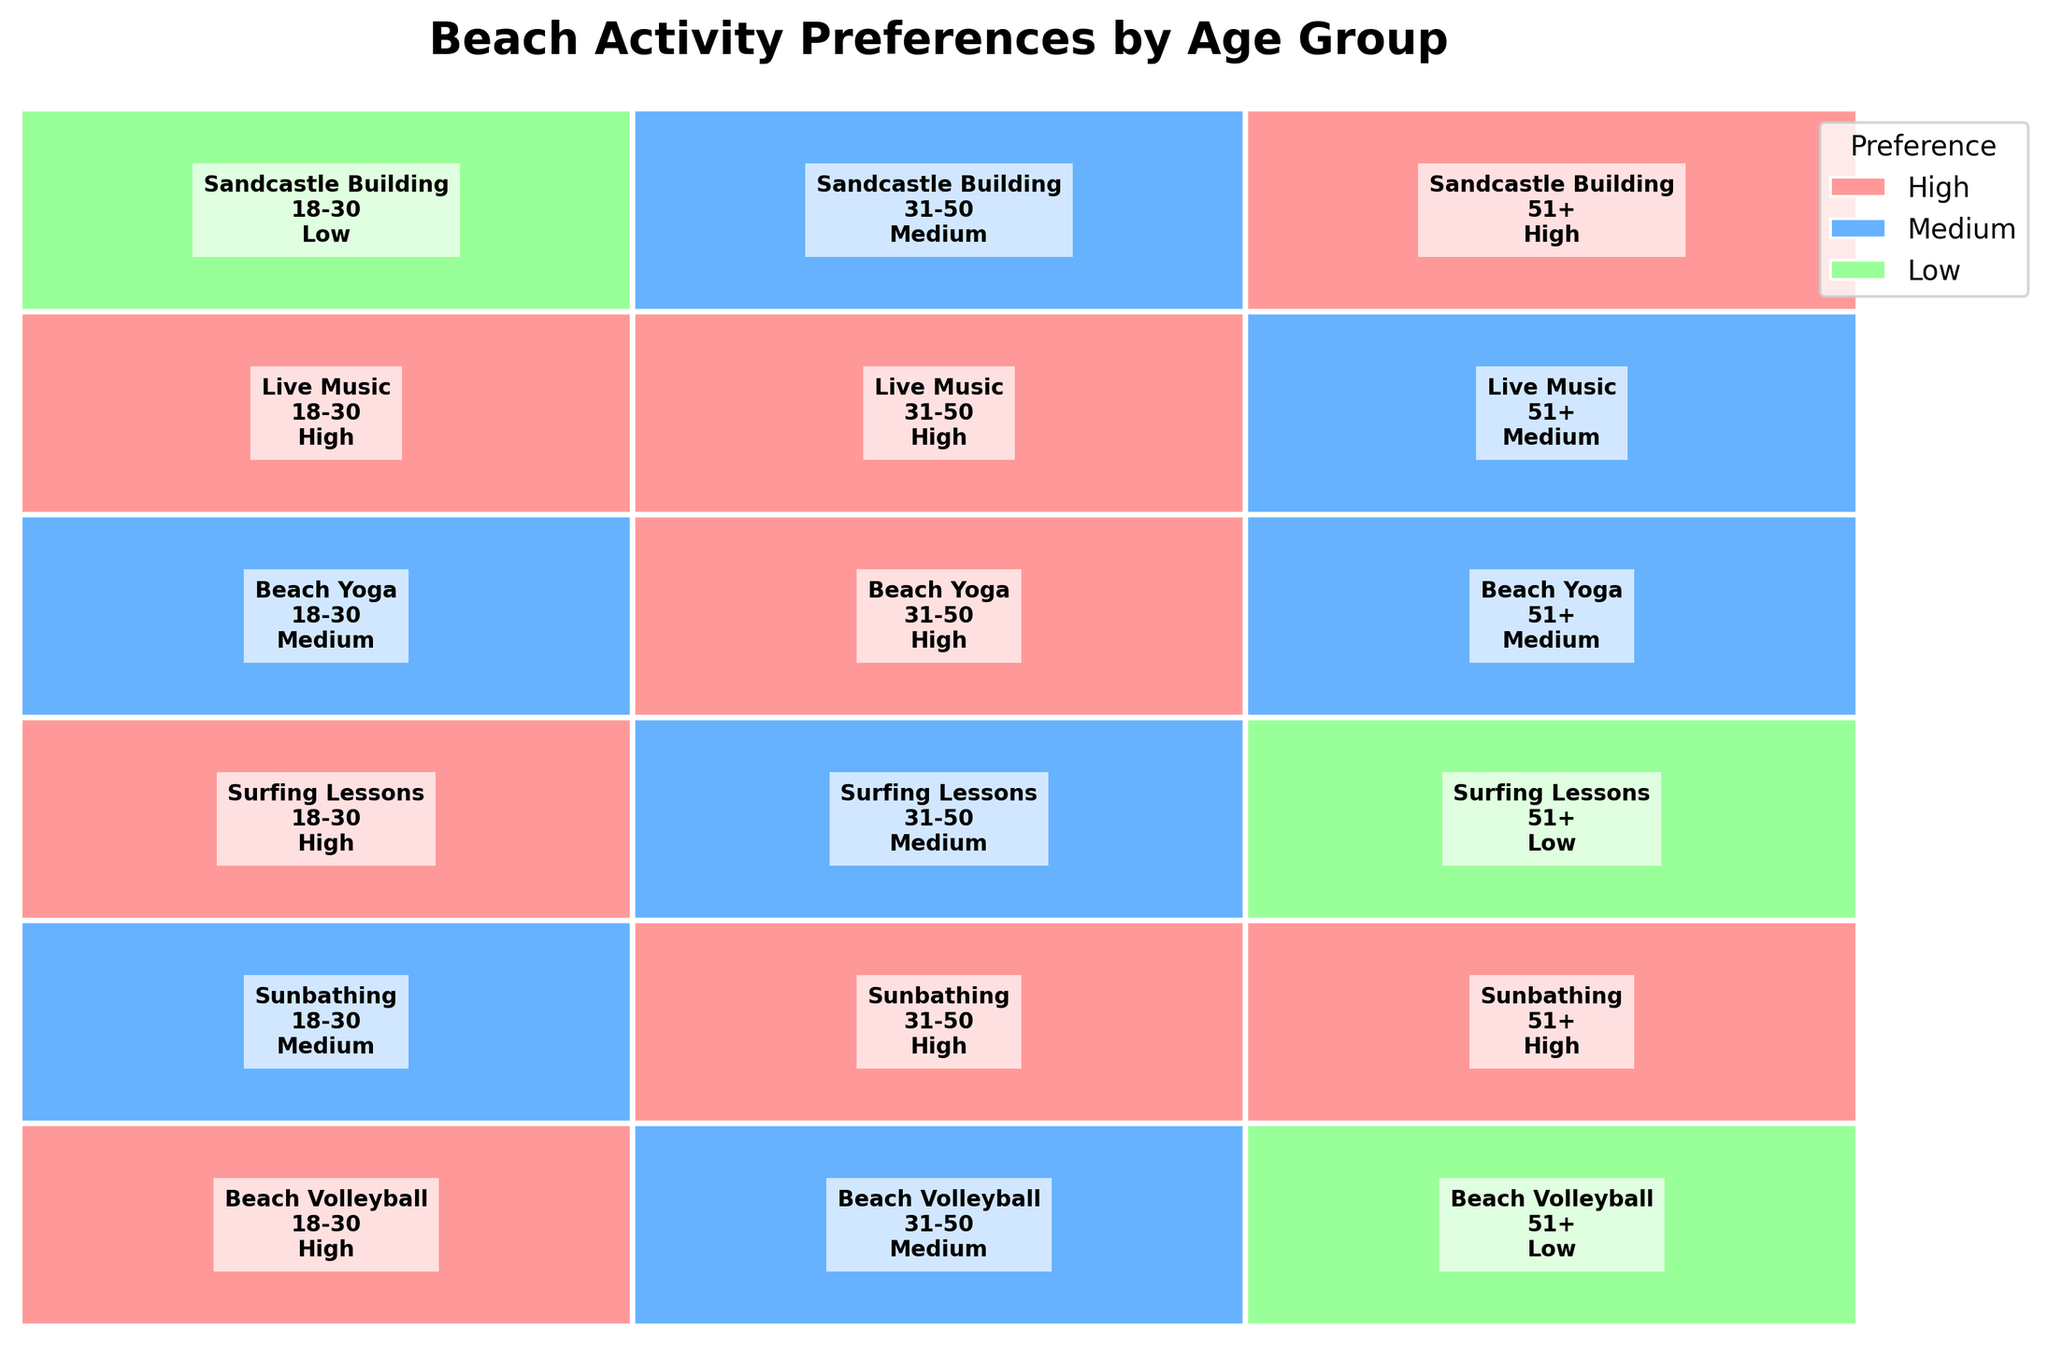What is the title of the plot? The title of the plot is written at the top of the figure. It says, "Beach Activity Preferences by Age Group."
Answer: Beach Activity Preferences by Age Group Which activity has the highest preference among the 18-30 age group? Looking at the section representing the 18-30 age group, "Live Music" has "High" preference color (light red) indicating it's the highest preference among this group.
Answer: Live Music Which age group has a low preference for Surfing Lessons? The section for "Surfing Lessons" can be identified, and within that, the "Low" preference color (light green) is associated with the age group 51+.
Answer: 51+ How do preferences for Beach Volleyball differ among the age groups? The 18-30 age group has a "High" preference (light red), 31-50 has a "Medium" preference (blue), and 51+ has a "Low" preference (light green) as indicated by the color coding in those sections.
Answer: 18-30: High, 31-50: Medium, 51+: Low Which activity do all age groups rate as high or medium? Looking across all age groups for each activity, "Sunbathing" and "Live Music" have "High" or "Medium" preferences across all age groups as shown by light red and blue sections.
Answer: Sunbathing and Live Music Do older age groups prefer Sandcastle Building more than the younger age groups? The preference for Sandcastle Building can be observed by noting colors for age groups - 51+ has "High" (light red), 31-50 has "Medium" (blue), and 18-30 has "Low" (light green), indicating increasing preference with age.
Answer: Yes What is the color code for a medium preference? In the legend, "Medium" preference is shown using the color blue.
Answer: Blue How do preferences for Beach Yoga change across the age groups? Observing the Beach Yoga sections, 18-30 shows "Medium" (blue), 31-50 shows "High" (light red), and 51+ shows "Medium" (blue).
Answer: 18-30: Medium, 31-50: High, 51+: Medium Which age group has the highest variety in preferences across all activities? Observing the color-coded preferences for each activity, the 18-30 age group has "High," "Medium," and "Low" preferences showing a higher variety compared to others.
Answer: 18-30 